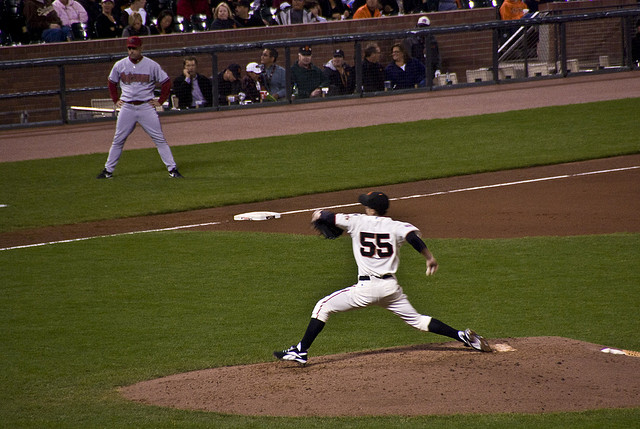Extract all visible text content from this image. 55 